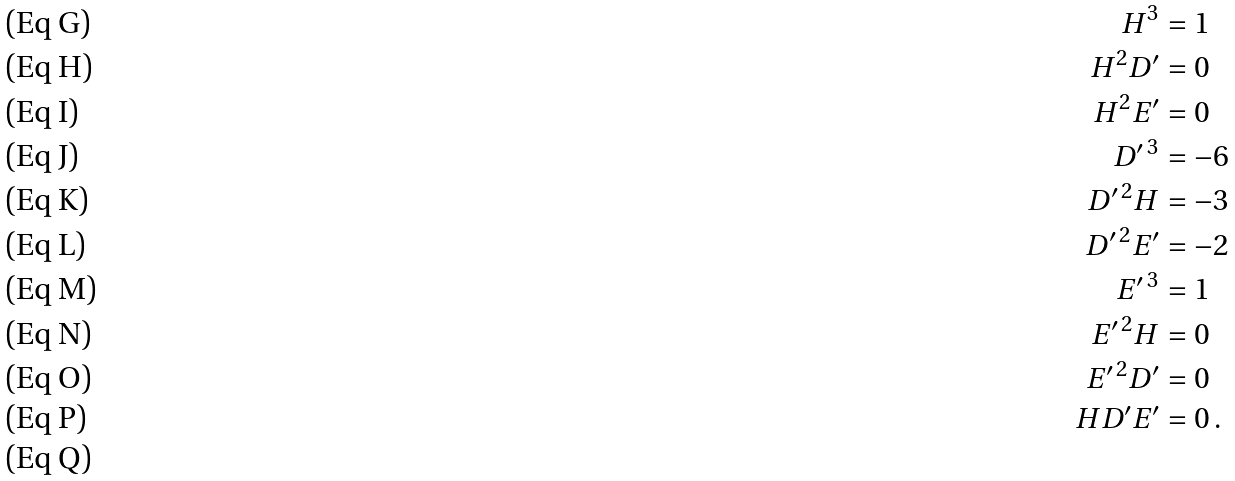<formula> <loc_0><loc_0><loc_500><loc_500>H ^ { 3 } & = 1 \\ H ^ { 2 } D ^ { \prime } & = 0 \\ H ^ { 2 } E ^ { \prime } & = 0 \\ D ^ { \prime \, 3 } & = - 6 \\ D ^ { \prime \, 2 } H & = - 3 \\ D ^ { \prime \, 2 } E ^ { \prime } & = - 2 \\ E ^ { \prime \, 3 } & = 1 \\ E ^ { \prime \, 2 } H & = 0 \\ E ^ { \prime \, 2 } D ^ { \prime } & = 0 \\ H D ^ { \prime } E ^ { \prime } & = 0 \, . \\</formula> 